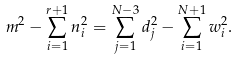Convert formula to latex. <formula><loc_0><loc_0><loc_500><loc_500>m ^ { 2 } - \sum _ { i = 1 } ^ { r + 1 } n _ { i } ^ { 2 } = \sum _ { j = 1 } ^ { N - 3 } d _ { j } ^ { 2 } - \sum _ { i = 1 } ^ { N + 1 } w _ { i } ^ { 2 } .</formula> 